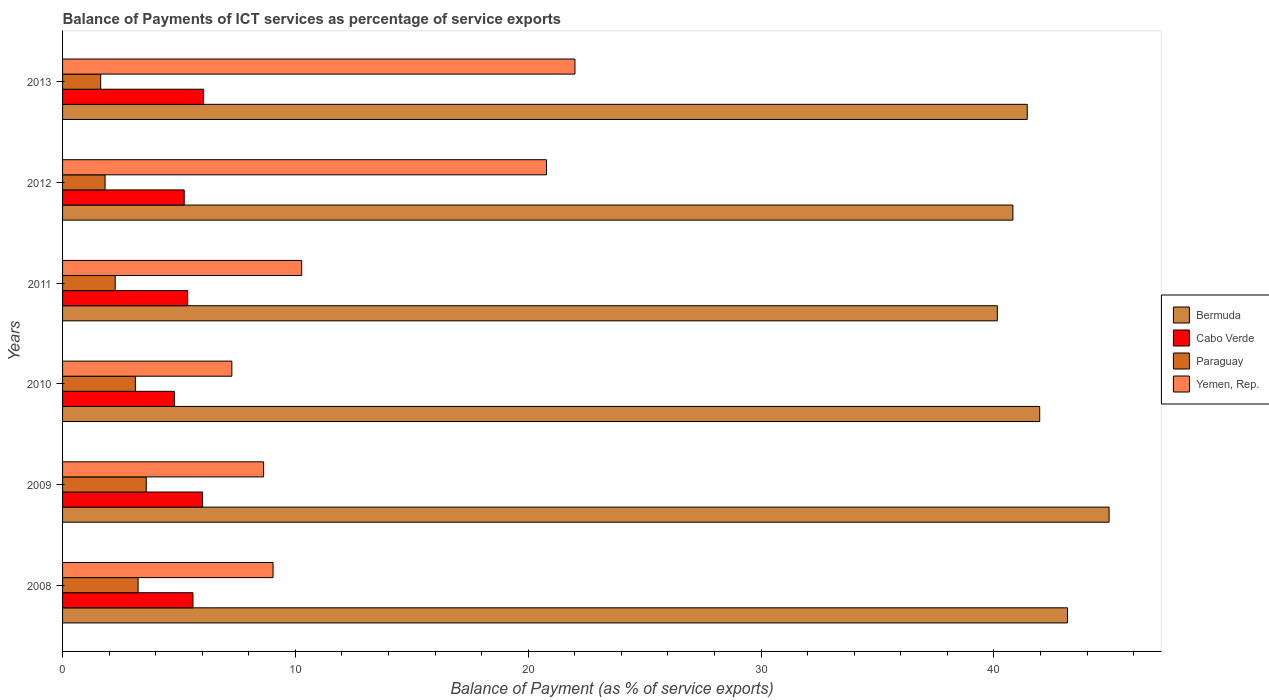How many different coloured bars are there?
Your answer should be compact. 4. Are the number of bars per tick equal to the number of legend labels?
Offer a very short reply. Yes. Are the number of bars on each tick of the Y-axis equal?
Give a very brief answer. Yes. How many bars are there on the 4th tick from the bottom?
Your answer should be compact. 4. What is the balance of payments of ICT services in Cabo Verde in 2010?
Keep it short and to the point. 4.8. Across all years, what is the maximum balance of payments of ICT services in Paraguay?
Offer a very short reply. 3.59. Across all years, what is the minimum balance of payments of ICT services in Cabo Verde?
Offer a terse response. 4.8. In which year was the balance of payments of ICT services in Cabo Verde maximum?
Provide a succinct answer. 2013. What is the total balance of payments of ICT services in Cabo Verde in the graph?
Your answer should be very brief. 33.07. What is the difference between the balance of payments of ICT services in Paraguay in 2011 and that in 2013?
Offer a very short reply. 0.62. What is the difference between the balance of payments of ICT services in Paraguay in 2008 and the balance of payments of ICT services in Cabo Verde in 2013?
Your response must be concise. -2.81. What is the average balance of payments of ICT services in Bermuda per year?
Offer a very short reply. 42.07. In the year 2013, what is the difference between the balance of payments of ICT services in Bermuda and balance of payments of ICT services in Paraguay?
Offer a very short reply. 39.79. In how many years, is the balance of payments of ICT services in Yemen, Rep. greater than 24 %?
Your answer should be compact. 0. What is the ratio of the balance of payments of ICT services in Bermuda in 2009 to that in 2011?
Offer a terse response. 1.12. Is the balance of payments of ICT services in Cabo Verde in 2010 less than that in 2011?
Your answer should be very brief. Yes. Is the difference between the balance of payments of ICT services in Bermuda in 2008 and 2010 greater than the difference between the balance of payments of ICT services in Paraguay in 2008 and 2010?
Make the answer very short. Yes. What is the difference between the highest and the second highest balance of payments of ICT services in Paraguay?
Provide a succinct answer. 0.35. What is the difference between the highest and the lowest balance of payments of ICT services in Paraguay?
Keep it short and to the point. 1.96. Is the sum of the balance of payments of ICT services in Bermuda in 2008 and 2011 greater than the maximum balance of payments of ICT services in Yemen, Rep. across all years?
Keep it short and to the point. Yes. What does the 4th bar from the top in 2008 represents?
Offer a very short reply. Bermuda. What does the 4th bar from the bottom in 2008 represents?
Offer a very short reply. Yemen, Rep. Is it the case that in every year, the sum of the balance of payments of ICT services in Cabo Verde and balance of payments of ICT services in Bermuda is greater than the balance of payments of ICT services in Yemen, Rep.?
Give a very brief answer. Yes. Are all the bars in the graph horizontal?
Your answer should be compact. Yes. How many years are there in the graph?
Ensure brevity in your answer.  6. What is the difference between two consecutive major ticks on the X-axis?
Your response must be concise. 10. Does the graph contain any zero values?
Keep it short and to the point. No. Where does the legend appear in the graph?
Offer a very short reply. Center right. How are the legend labels stacked?
Offer a very short reply. Vertical. What is the title of the graph?
Provide a succinct answer. Balance of Payments of ICT services as percentage of service exports. Does "Lao PDR" appear as one of the legend labels in the graph?
Provide a succinct answer. No. What is the label or title of the X-axis?
Offer a terse response. Balance of Payment (as % of service exports). What is the label or title of the Y-axis?
Make the answer very short. Years. What is the Balance of Payment (as % of service exports) in Bermuda in 2008?
Give a very brief answer. 43.16. What is the Balance of Payment (as % of service exports) in Cabo Verde in 2008?
Your response must be concise. 5.6. What is the Balance of Payment (as % of service exports) in Paraguay in 2008?
Your answer should be very brief. 3.24. What is the Balance of Payment (as % of service exports) of Yemen, Rep. in 2008?
Provide a short and direct response. 9.04. What is the Balance of Payment (as % of service exports) in Bermuda in 2009?
Your answer should be very brief. 44.94. What is the Balance of Payment (as % of service exports) of Cabo Verde in 2009?
Give a very brief answer. 6.01. What is the Balance of Payment (as % of service exports) in Paraguay in 2009?
Your answer should be compact. 3.59. What is the Balance of Payment (as % of service exports) in Yemen, Rep. in 2009?
Your response must be concise. 8.63. What is the Balance of Payment (as % of service exports) of Bermuda in 2010?
Ensure brevity in your answer.  41.96. What is the Balance of Payment (as % of service exports) in Cabo Verde in 2010?
Your response must be concise. 4.8. What is the Balance of Payment (as % of service exports) of Paraguay in 2010?
Offer a terse response. 3.13. What is the Balance of Payment (as % of service exports) in Yemen, Rep. in 2010?
Provide a succinct answer. 7.27. What is the Balance of Payment (as % of service exports) of Bermuda in 2011?
Provide a succinct answer. 40.14. What is the Balance of Payment (as % of service exports) in Cabo Verde in 2011?
Make the answer very short. 5.37. What is the Balance of Payment (as % of service exports) in Paraguay in 2011?
Give a very brief answer. 2.26. What is the Balance of Payment (as % of service exports) in Yemen, Rep. in 2011?
Provide a short and direct response. 10.27. What is the Balance of Payment (as % of service exports) in Bermuda in 2012?
Offer a very short reply. 40.81. What is the Balance of Payment (as % of service exports) in Cabo Verde in 2012?
Your response must be concise. 5.22. What is the Balance of Payment (as % of service exports) of Paraguay in 2012?
Ensure brevity in your answer.  1.83. What is the Balance of Payment (as % of service exports) of Yemen, Rep. in 2012?
Keep it short and to the point. 20.78. What is the Balance of Payment (as % of service exports) in Bermuda in 2013?
Offer a terse response. 41.43. What is the Balance of Payment (as % of service exports) in Cabo Verde in 2013?
Offer a very short reply. 6.05. What is the Balance of Payment (as % of service exports) in Paraguay in 2013?
Give a very brief answer. 1.64. What is the Balance of Payment (as % of service exports) of Yemen, Rep. in 2013?
Provide a succinct answer. 22. Across all years, what is the maximum Balance of Payment (as % of service exports) of Bermuda?
Offer a very short reply. 44.94. Across all years, what is the maximum Balance of Payment (as % of service exports) in Cabo Verde?
Give a very brief answer. 6.05. Across all years, what is the maximum Balance of Payment (as % of service exports) of Paraguay?
Your answer should be compact. 3.59. Across all years, what is the maximum Balance of Payment (as % of service exports) of Yemen, Rep.?
Keep it short and to the point. 22. Across all years, what is the minimum Balance of Payment (as % of service exports) in Bermuda?
Your answer should be compact. 40.14. Across all years, what is the minimum Balance of Payment (as % of service exports) of Cabo Verde?
Your answer should be compact. 4.8. Across all years, what is the minimum Balance of Payment (as % of service exports) in Paraguay?
Ensure brevity in your answer.  1.64. Across all years, what is the minimum Balance of Payment (as % of service exports) in Yemen, Rep.?
Keep it short and to the point. 7.27. What is the total Balance of Payment (as % of service exports) of Bermuda in the graph?
Provide a short and direct response. 252.45. What is the total Balance of Payment (as % of service exports) in Cabo Verde in the graph?
Your answer should be very brief. 33.07. What is the total Balance of Payment (as % of service exports) in Paraguay in the graph?
Provide a short and direct response. 15.69. What is the total Balance of Payment (as % of service exports) in Yemen, Rep. in the graph?
Provide a succinct answer. 78. What is the difference between the Balance of Payment (as % of service exports) of Bermuda in 2008 and that in 2009?
Make the answer very short. -1.79. What is the difference between the Balance of Payment (as % of service exports) in Cabo Verde in 2008 and that in 2009?
Keep it short and to the point. -0.41. What is the difference between the Balance of Payment (as % of service exports) in Paraguay in 2008 and that in 2009?
Your response must be concise. -0.35. What is the difference between the Balance of Payment (as % of service exports) of Yemen, Rep. in 2008 and that in 2009?
Give a very brief answer. 0.41. What is the difference between the Balance of Payment (as % of service exports) of Bermuda in 2008 and that in 2010?
Your answer should be compact. 1.19. What is the difference between the Balance of Payment (as % of service exports) in Cabo Verde in 2008 and that in 2010?
Offer a terse response. 0.8. What is the difference between the Balance of Payment (as % of service exports) in Paraguay in 2008 and that in 2010?
Your answer should be compact. 0.12. What is the difference between the Balance of Payment (as % of service exports) of Yemen, Rep. in 2008 and that in 2010?
Offer a terse response. 1.77. What is the difference between the Balance of Payment (as % of service exports) of Bermuda in 2008 and that in 2011?
Your answer should be compact. 3.01. What is the difference between the Balance of Payment (as % of service exports) in Cabo Verde in 2008 and that in 2011?
Make the answer very short. 0.23. What is the difference between the Balance of Payment (as % of service exports) in Paraguay in 2008 and that in 2011?
Keep it short and to the point. 0.98. What is the difference between the Balance of Payment (as % of service exports) of Yemen, Rep. in 2008 and that in 2011?
Make the answer very short. -1.23. What is the difference between the Balance of Payment (as % of service exports) in Bermuda in 2008 and that in 2012?
Give a very brief answer. 2.34. What is the difference between the Balance of Payment (as % of service exports) of Cabo Verde in 2008 and that in 2012?
Provide a succinct answer. 0.38. What is the difference between the Balance of Payment (as % of service exports) of Paraguay in 2008 and that in 2012?
Ensure brevity in your answer.  1.42. What is the difference between the Balance of Payment (as % of service exports) of Yemen, Rep. in 2008 and that in 2012?
Offer a very short reply. -11.74. What is the difference between the Balance of Payment (as % of service exports) in Bermuda in 2008 and that in 2013?
Provide a succinct answer. 1.73. What is the difference between the Balance of Payment (as % of service exports) in Cabo Verde in 2008 and that in 2013?
Your response must be concise. -0.45. What is the difference between the Balance of Payment (as % of service exports) of Paraguay in 2008 and that in 2013?
Your answer should be very brief. 1.61. What is the difference between the Balance of Payment (as % of service exports) in Yemen, Rep. in 2008 and that in 2013?
Make the answer very short. -12.96. What is the difference between the Balance of Payment (as % of service exports) of Bermuda in 2009 and that in 2010?
Offer a terse response. 2.98. What is the difference between the Balance of Payment (as % of service exports) of Cabo Verde in 2009 and that in 2010?
Provide a succinct answer. 1.21. What is the difference between the Balance of Payment (as % of service exports) in Paraguay in 2009 and that in 2010?
Give a very brief answer. 0.47. What is the difference between the Balance of Payment (as % of service exports) in Yemen, Rep. in 2009 and that in 2010?
Offer a terse response. 1.36. What is the difference between the Balance of Payment (as % of service exports) in Bermuda in 2009 and that in 2011?
Provide a succinct answer. 4.8. What is the difference between the Balance of Payment (as % of service exports) in Cabo Verde in 2009 and that in 2011?
Offer a terse response. 0.64. What is the difference between the Balance of Payment (as % of service exports) in Paraguay in 2009 and that in 2011?
Provide a short and direct response. 1.33. What is the difference between the Balance of Payment (as % of service exports) in Yemen, Rep. in 2009 and that in 2011?
Ensure brevity in your answer.  -1.64. What is the difference between the Balance of Payment (as % of service exports) in Bermuda in 2009 and that in 2012?
Provide a succinct answer. 4.13. What is the difference between the Balance of Payment (as % of service exports) of Cabo Verde in 2009 and that in 2012?
Provide a short and direct response. 0.79. What is the difference between the Balance of Payment (as % of service exports) of Paraguay in 2009 and that in 2012?
Ensure brevity in your answer.  1.77. What is the difference between the Balance of Payment (as % of service exports) of Yemen, Rep. in 2009 and that in 2012?
Keep it short and to the point. -12.15. What is the difference between the Balance of Payment (as % of service exports) in Bermuda in 2009 and that in 2013?
Your response must be concise. 3.51. What is the difference between the Balance of Payment (as % of service exports) of Cabo Verde in 2009 and that in 2013?
Offer a terse response. -0.04. What is the difference between the Balance of Payment (as % of service exports) of Paraguay in 2009 and that in 2013?
Offer a very short reply. 1.96. What is the difference between the Balance of Payment (as % of service exports) in Yemen, Rep. in 2009 and that in 2013?
Your answer should be very brief. -13.37. What is the difference between the Balance of Payment (as % of service exports) of Bermuda in 2010 and that in 2011?
Offer a very short reply. 1.82. What is the difference between the Balance of Payment (as % of service exports) in Cabo Verde in 2010 and that in 2011?
Make the answer very short. -0.57. What is the difference between the Balance of Payment (as % of service exports) of Paraguay in 2010 and that in 2011?
Your answer should be very brief. 0.87. What is the difference between the Balance of Payment (as % of service exports) of Yemen, Rep. in 2010 and that in 2011?
Give a very brief answer. -3. What is the difference between the Balance of Payment (as % of service exports) of Bermuda in 2010 and that in 2012?
Provide a succinct answer. 1.15. What is the difference between the Balance of Payment (as % of service exports) of Cabo Verde in 2010 and that in 2012?
Provide a short and direct response. -0.42. What is the difference between the Balance of Payment (as % of service exports) in Paraguay in 2010 and that in 2012?
Your answer should be compact. 1.3. What is the difference between the Balance of Payment (as % of service exports) in Yemen, Rep. in 2010 and that in 2012?
Provide a succinct answer. -13.51. What is the difference between the Balance of Payment (as % of service exports) of Bermuda in 2010 and that in 2013?
Offer a very short reply. 0.53. What is the difference between the Balance of Payment (as % of service exports) of Cabo Verde in 2010 and that in 2013?
Your answer should be very brief. -1.25. What is the difference between the Balance of Payment (as % of service exports) in Paraguay in 2010 and that in 2013?
Offer a very short reply. 1.49. What is the difference between the Balance of Payment (as % of service exports) in Yemen, Rep. in 2010 and that in 2013?
Offer a very short reply. -14.73. What is the difference between the Balance of Payment (as % of service exports) in Bermuda in 2011 and that in 2012?
Your answer should be compact. -0.67. What is the difference between the Balance of Payment (as % of service exports) of Cabo Verde in 2011 and that in 2012?
Ensure brevity in your answer.  0.15. What is the difference between the Balance of Payment (as % of service exports) of Paraguay in 2011 and that in 2012?
Your response must be concise. 0.44. What is the difference between the Balance of Payment (as % of service exports) of Yemen, Rep. in 2011 and that in 2012?
Give a very brief answer. -10.51. What is the difference between the Balance of Payment (as % of service exports) in Bermuda in 2011 and that in 2013?
Offer a terse response. -1.28. What is the difference between the Balance of Payment (as % of service exports) in Cabo Verde in 2011 and that in 2013?
Make the answer very short. -0.68. What is the difference between the Balance of Payment (as % of service exports) of Paraguay in 2011 and that in 2013?
Keep it short and to the point. 0.62. What is the difference between the Balance of Payment (as % of service exports) of Yemen, Rep. in 2011 and that in 2013?
Offer a very short reply. -11.74. What is the difference between the Balance of Payment (as % of service exports) in Bermuda in 2012 and that in 2013?
Give a very brief answer. -0.62. What is the difference between the Balance of Payment (as % of service exports) in Cabo Verde in 2012 and that in 2013?
Ensure brevity in your answer.  -0.83. What is the difference between the Balance of Payment (as % of service exports) of Paraguay in 2012 and that in 2013?
Offer a very short reply. 0.19. What is the difference between the Balance of Payment (as % of service exports) in Yemen, Rep. in 2012 and that in 2013?
Your response must be concise. -1.22. What is the difference between the Balance of Payment (as % of service exports) of Bermuda in 2008 and the Balance of Payment (as % of service exports) of Cabo Verde in 2009?
Provide a succinct answer. 37.14. What is the difference between the Balance of Payment (as % of service exports) of Bermuda in 2008 and the Balance of Payment (as % of service exports) of Paraguay in 2009?
Make the answer very short. 39.56. What is the difference between the Balance of Payment (as % of service exports) in Bermuda in 2008 and the Balance of Payment (as % of service exports) in Yemen, Rep. in 2009?
Offer a terse response. 34.52. What is the difference between the Balance of Payment (as % of service exports) in Cabo Verde in 2008 and the Balance of Payment (as % of service exports) in Paraguay in 2009?
Offer a very short reply. 2.01. What is the difference between the Balance of Payment (as % of service exports) in Cabo Verde in 2008 and the Balance of Payment (as % of service exports) in Yemen, Rep. in 2009?
Offer a very short reply. -3.03. What is the difference between the Balance of Payment (as % of service exports) of Paraguay in 2008 and the Balance of Payment (as % of service exports) of Yemen, Rep. in 2009?
Make the answer very short. -5.39. What is the difference between the Balance of Payment (as % of service exports) of Bermuda in 2008 and the Balance of Payment (as % of service exports) of Cabo Verde in 2010?
Offer a very short reply. 38.35. What is the difference between the Balance of Payment (as % of service exports) in Bermuda in 2008 and the Balance of Payment (as % of service exports) in Paraguay in 2010?
Your answer should be compact. 40.03. What is the difference between the Balance of Payment (as % of service exports) of Bermuda in 2008 and the Balance of Payment (as % of service exports) of Yemen, Rep. in 2010?
Provide a short and direct response. 35.89. What is the difference between the Balance of Payment (as % of service exports) in Cabo Verde in 2008 and the Balance of Payment (as % of service exports) in Paraguay in 2010?
Your answer should be very brief. 2.47. What is the difference between the Balance of Payment (as % of service exports) in Cabo Verde in 2008 and the Balance of Payment (as % of service exports) in Yemen, Rep. in 2010?
Offer a terse response. -1.67. What is the difference between the Balance of Payment (as % of service exports) in Paraguay in 2008 and the Balance of Payment (as % of service exports) in Yemen, Rep. in 2010?
Your response must be concise. -4.03. What is the difference between the Balance of Payment (as % of service exports) in Bermuda in 2008 and the Balance of Payment (as % of service exports) in Cabo Verde in 2011?
Your response must be concise. 37.78. What is the difference between the Balance of Payment (as % of service exports) in Bermuda in 2008 and the Balance of Payment (as % of service exports) in Paraguay in 2011?
Your response must be concise. 40.9. What is the difference between the Balance of Payment (as % of service exports) in Bermuda in 2008 and the Balance of Payment (as % of service exports) in Yemen, Rep. in 2011?
Your answer should be very brief. 32.89. What is the difference between the Balance of Payment (as % of service exports) in Cabo Verde in 2008 and the Balance of Payment (as % of service exports) in Paraguay in 2011?
Your response must be concise. 3.34. What is the difference between the Balance of Payment (as % of service exports) of Cabo Verde in 2008 and the Balance of Payment (as % of service exports) of Yemen, Rep. in 2011?
Your answer should be very brief. -4.67. What is the difference between the Balance of Payment (as % of service exports) in Paraguay in 2008 and the Balance of Payment (as % of service exports) in Yemen, Rep. in 2011?
Your answer should be very brief. -7.02. What is the difference between the Balance of Payment (as % of service exports) of Bermuda in 2008 and the Balance of Payment (as % of service exports) of Cabo Verde in 2012?
Provide a succinct answer. 37.93. What is the difference between the Balance of Payment (as % of service exports) in Bermuda in 2008 and the Balance of Payment (as % of service exports) in Paraguay in 2012?
Your answer should be very brief. 41.33. What is the difference between the Balance of Payment (as % of service exports) in Bermuda in 2008 and the Balance of Payment (as % of service exports) in Yemen, Rep. in 2012?
Ensure brevity in your answer.  22.37. What is the difference between the Balance of Payment (as % of service exports) of Cabo Verde in 2008 and the Balance of Payment (as % of service exports) of Paraguay in 2012?
Provide a succinct answer. 3.77. What is the difference between the Balance of Payment (as % of service exports) in Cabo Verde in 2008 and the Balance of Payment (as % of service exports) in Yemen, Rep. in 2012?
Your answer should be compact. -15.18. What is the difference between the Balance of Payment (as % of service exports) in Paraguay in 2008 and the Balance of Payment (as % of service exports) in Yemen, Rep. in 2012?
Offer a very short reply. -17.54. What is the difference between the Balance of Payment (as % of service exports) in Bermuda in 2008 and the Balance of Payment (as % of service exports) in Cabo Verde in 2013?
Provide a short and direct response. 37.1. What is the difference between the Balance of Payment (as % of service exports) of Bermuda in 2008 and the Balance of Payment (as % of service exports) of Paraguay in 2013?
Make the answer very short. 41.52. What is the difference between the Balance of Payment (as % of service exports) in Bermuda in 2008 and the Balance of Payment (as % of service exports) in Yemen, Rep. in 2013?
Your answer should be compact. 21.15. What is the difference between the Balance of Payment (as % of service exports) of Cabo Verde in 2008 and the Balance of Payment (as % of service exports) of Paraguay in 2013?
Your answer should be compact. 3.96. What is the difference between the Balance of Payment (as % of service exports) in Cabo Verde in 2008 and the Balance of Payment (as % of service exports) in Yemen, Rep. in 2013?
Your response must be concise. -16.4. What is the difference between the Balance of Payment (as % of service exports) of Paraguay in 2008 and the Balance of Payment (as % of service exports) of Yemen, Rep. in 2013?
Ensure brevity in your answer.  -18.76. What is the difference between the Balance of Payment (as % of service exports) in Bermuda in 2009 and the Balance of Payment (as % of service exports) in Cabo Verde in 2010?
Provide a succinct answer. 40.14. What is the difference between the Balance of Payment (as % of service exports) of Bermuda in 2009 and the Balance of Payment (as % of service exports) of Paraguay in 2010?
Offer a terse response. 41.82. What is the difference between the Balance of Payment (as % of service exports) of Bermuda in 2009 and the Balance of Payment (as % of service exports) of Yemen, Rep. in 2010?
Your answer should be compact. 37.67. What is the difference between the Balance of Payment (as % of service exports) of Cabo Verde in 2009 and the Balance of Payment (as % of service exports) of Paraguay in 2010?
Offer a very short reply. 2.88. What is the difference between the Balance of Payment (as % of service exports) in Cabo Verde in 2009 and the Balance of Payment (as % of service exports) in Yemen, Rep. in 2010?
Ensure brevity in your answer.  -1.26. What is the difference between the Balance of Payment (as % of service exports) in Paraguay in 2009 and the Balance of Payment (as % of service exports) in Yemen, Rep. in 2010?
Provide a succinct answer. -3.68. What is the difference between the Balance of Payment (as % of service exports) in Bermuda in 2009 and the Balance of Payment (as % of service exports) in Cabo Verde in 2011?
Give a very brief answer. 39.57. What is the difference between the Balance of Payment (as % of service exports) of Bermuda in 2009 and the Balance of Payment (as % of service exports) of Paraguay in 2011?
Make the answer very short. 42.68. What is the difference between the Balance of Payment (as % of service exports) of Bermuda in 2009 and the Balance of Payment (as % of service exports) of Yemen, Rep. in 2011?
Your response must be concise. 34.67. What is the difference between the Balance of Payment (as % of service exports) in Cabo Verde in 2009 and the Balance of Payment (as % of service exports) in Paraguay in 2011?
Keep it short and to the point. 3.75. What is the difference between the Balance of Payment (as % of service exports) of Cabo Verde in 2009 and the Balance of Payment (as % of service exports) of Yemen, Rep. in 2011?
Your response must be concise. -4.26. What is the difference between the Balance of Payment (as % of service exports) of Paraguay in 2009 and the Balance of Payment (as % of service exports) of Yemen, Rep. in 2011?
Offer a terse response. -6.67. What is the difference between the Balance of Payment (as % of service exports) in Bermuda in 2009 and the Balance of Payment (as % of service exports) in Cabo Verde in 2012?
Provide a succinct answer. 39.72. What is the difference between the Balance of Payment (as % of service exports) in Bermuda in 2009 and the Balance of Payment (as % of service exports) in Paraguay in 2012?
Your response must be concise. 43.12. What is the difference between the Balance of Payment (as % of service exports) in Bermuda in 2009 and the Balance of Payment (as % of service exports) in Yemen, Rep. in 2012?
Keep it short and to the point. 24.16. What is the difference between the Balance of Payment (as % of service exports) in Cabo Verde in 2009 and the Balance of Payment (as % of service exports) in Paraguay in 2012?
Make the answer very short. 4.19. What is the difference between the Balance of Payment (as % of service exports) in Cabo Verde in 2009 and the Balance of Payment (as % of service exports) in Yemen, Rep. in 2012?
Offer a terse response. -14.77. What is the difference between the Balance of Payment (as % of service exports) of Paraguay in 2009 and the Balance of Payment (as % of service exports) of Yemen, Rep. in 2012?
Offer a terse response. -17.19. What is the difference between the Balance of Payment (as % of service exports) in Bermuda in 2009 and the Balance of Payment (as % of service exports) in Cabo Verde in 2013?
Your answer should be compact. 38.89. What is the difference between the Balance of Payment (as % of service exports) of Bermuda in 2009 and the Balance of Payment (as % of service exports) of Paraguay in 2013?
Keep it short and to the point. 43.3. What is the difference between the Balance of Payment (as % of service exports) of Bermuda in 2009 and the Balance of Payment (as % of service exports) of Yemen, Rep. in 2013?
Ensure brevity in your answer.  22.94. What is the difference between the Balance of Payment (as % of service exports) of Cabo Verde in 2009 and the Balance of Payment (as % of service exports) of Paraguay in 2013?
Your response must be concise. 4.37. What is the difference between the Balance of Payment (as % of service exports) of Cabo Verde in 2009 and the Balance of Payment (as % of service exports) of Yemen, Rep. in 2013?
Your response must be concise. -15.99. What is the difference between the Balance of Payment (as % of service exports) of Paraguay in 2009 and the Balance of Payment (as % of service exports) of Yemen, Rep. in 2013?
Give a very brief answer. -18.41. What is the difference between the Balance of Payment (as % of service exports) of Bermuda in 2010 and the Balance of Payment (as % of service exports) of Cabo Verde in 2011?
Your response must be concise. 36.59. What is the difference between the Balance of Payment (as % of service exports) of Bermuda in 2010 and the Balance of Payment (as % of service exports) of Paraguay in 2011?
Give a very brief answer. 39.7. What is the difference between the Balance of Payment (as % of service exports) in Bermuda in 2010 and the Balance of Payment (as % of service exports) in Yemen, Rep. in 2011?
Your answer should be compact. 31.7. What is the difference between the Balance of Payment (as % of service exports) in Cabo Verde in 2010 and the Balance of Payment (as % of service exports) in Paraguay in 2011?
Offer a terse response. 2.54. What is the difference between the Balance of Payment (as % of service exports) of Cabo Verde in 2010 and the Balance of Payment (as % of service exports) of Yemen, Rep. in 2011?
Your response must be concise. -5.46. What is the difference between the Balance of Payment (as % of service exports) in Paraguay in 2010 and the Balance of Payment (as % of service exports) in Yemen, Rep. in 2011?
Your response must be concise. -7.14. What is the difference between the Balance of Payment (as % of service exports) in Bermuda in 2010 and the Balance of Payment (as % of service exports) in Cabo Verde in 2012?
Offer a terse response. 36.74. What is the difference between the Balance of Payment (as % of service exports) of Bermuda in 2010 and the Balance of Payment (as % of service exports) of Paraguay in 2012?
Give a very brief answer. 40.14. What is the difference between the Balance of Payment (as % of service exports) in Bermuda in 2010 and the Balance of Payment (as % of service exports) in Yemen, Rep. in 2012?
Provide a succinct answer. 21.18. What is the difference between the Balance of Payment (as % of service exports) in Cabo Verde in 2010 and the Balance of Payment (as % of service exports) in Paraguay in 2012?
Keep it short and to the point. 2.98. What is the difference between the Balance of Payment (as % of service exports) in Cabo Verde in 2010 and the Balance of Payment (as % of service exports) in Yemen, Rep. in 2012?
Offer a terse response. -15.98. What is the difference between the Balance of Payment (as % of service exports) of Paraguay in 2010 and the Balance of Payment (as % of service exports) of Yemen, Rep. in 2012?
Your answer should be very brief. -17.65. What is the difference between the Balance of Payment (as % of service exports) in Bermuda in 2010 and the Balance of Payment (as % of service exports) in Cabo Verde in 2013?
Offer a terse response. 35.91. What is the difference between the Balance of Payment (as % of service exports) of Bermuda in 2010 and the Balance of Payment (as % of service exports) of Paraguay in 2013?
Keep it short and to the point. 40.33. What is the difference between the Balance of Payment (as % of service exports) of Bermuda in 2010 and the Balance of Payment (as % of service exports) of Yemen, Rep. in 2013?
Keep it short and to the point. 19.96. What is the difference between the Balance of Payment (as % of service exports) of Cabo Verde in 2010 and the Balance of Payment (as % of service exports) of Paraguay in 2013?
Your answer should be compact. 3.17. What is the difference between the Balance of Payment (as % of service exports) of Cabo Verde in 2010 and the Balance of Payment (as % of service exports) of Yemen, Rep. in 2013?
Provide a succinct answer. -17.2. What is the difference between the Balance of Payment (as % of service exports) of Paraguay in 2010 and the Balance of Payment (as % of service exports) of Yemen, Rep. in 2013?
Offer a very short reply. -18.88. What is the difference between the Balance of Payment (as % of service exports) in Bermuda in 2011 and the Balance of Payment (as % of service exports) in Cabo Verde in 2012?
Make the answer very short. 34.92. What is the difference between the Balance of Payment (as % of service exports) of Bermuda in 2011 and the Balance of Payment (as % of service exports) of Paraguay in 2012?
Offer a terse response. 38.32. What is the difference between the Balance of Payment (as % of service exports) in Bermuda in 2011 and the Balance of Payment (as % of service exports) in Yemen, Rep. in 2012?
Make the answer very short. 19.36. What is the difference between the Balance of Payment (as % of service exports) in Cabo Verde in 2011 and the Balance of Payment (as % of service exports) in Paraguay in 2012?
Offer a very short reply. 3.55. What is the difference between the Balance of Payment (as % of service exports) in Cabo Verde in 2011 and the Balance of Payment (as % of service exports) in Yemen, Rep. in 2012?
Give a very brief answer. -15.41. What is the difference between the Balance of Payment (as % of service exports) in Paraguay in 2011 and the Balance of Payment (as % of service exports) in Yemen, Rep. in 2012?
Offer a very short reply. -18.52. What is the difference between the Balance of Payment (as % of service exports) in Bermuda in 2011 and the Balance of Payment (as % of service exports) in Cabo Verde in 2013?
Provide a short and direct response. 34.09. What is the difference between the Balance of Payment (as % of service exports) of Bermuda in 2011 and the Balance of Payment (as % of service exports) of Paraguay in 2013?
Your answer should be very brief. 38.51. What is the difference between the Balance of Payment (as % of service exports) in Bermuda in 2011 and the Balance of Payment (as % of service exports) in Yemen, Rep. in 2013?
Your response must be concise. 18.14. What is the difference between the Balance of Payment (as % of service exports) in Cabo Verde in 2011 and the Balance of Payment (as % of service exports) in Paraguay in 2013?
Make the answer very short. 3.73. What is the difference between the Balance of Payment (as % of service exports) of Cabo Verde in 2011 and the Balance of Payment (as % of service exports) of Yemen, Rep. in 2013?
Give a very brief answer. -16.63. What is the difference between the Balance of Payment (as % of service exports) in Paraguay in 2011 and the Balance of Payment (as % of service exports) in Yemen, Rep. in 2013?
Your response must be concise. -19.74. What is the difference between the Balance of Payment (as % of service exports) of Bermuda in 2012 and the Balance of Payment (as % of service exports) of Cabo Verde in 2013?
Offer a terse response. 34.76. What is the difference between the Balance of Payment (as % of service exports) in Bermuda in 2012 and the Balance of Payment (as % of service exports) in Paraguay in 2013?
Make the answer very short. 39.17. What is the difference between the Balance of Payment (as % of service exports) of Bermuda in 2012 and the Balance of Payment (as % of service exports) of Yemen, Rep. in 2013?
Provide a short and direct response. 18.81. What is the difference between the Balance of Payment (as % of service exports) in Cabo Verde in 2012 and the Balance of Payment (as % of service exports) in Paraguay in 2013?
Offer a very short reply. 3.59. What is the difference between the Balance of Payment (as % of service exports) in Cabo Verde in 2012 and the Balance of Payment (as % of service exports) in Yemen, Rep. in 2013?
Offer a very short reply. -16.78. What is the difference between the Balance of Payment (as % of service exports) of Paraguay in 2012 and the Balance of Payment (as % of service exports) of Yemen, Rep. in 2013?
Provide a succinct answer. -20.18. What is the average Balance of Payment (as % of service exports) in Bermuda per year?
Offer a terse response. 42.07. What is the average Balance of Payment (as % of service exports) in Cabo Verde per year?
Provide a short and direct response. 5.51. What is the average Balance of Payment (as % of service exports) of Paraguay per year?
Your answer should be compact. 2.62. What is the average Balance of Payment (as % of service exports) of Yemen, Rep. per year?
Give a very brief answer. 13. In the year 2008, what is the difference between the Balance of Payment (as % of service exports) of Bermuda and Balance of Payment (as % of service exports) of Cabo Verde?
Offer a very short reply. 37.56. In the year 2008, what is the difference between the Balance of Payment (as % of service exports) in Bermuda and Balance of Payment (as % of service exports) in Paraguay?
Ensure brevity in your answer.  39.91. In the year 2008, what is the difference between the Balance of Payment (as % of service exports) of Bermuda and Balance of Payment (as % of service exports) of Yemen, Rep.?
Make the answer very short. 34.12. In the year 2008, what is the difference between the Balance of Payment (as % of service exports) in Cabo Verde and Balance of Payment (as % of service exports) in Paraguay?
Provide a short and direct response. 2.36. In the year 2008, what is the difference between the Balance of Payment (as % of service exports) of Cabo Verde and Balance of Payment (as % of service exports) of Yemen, Rep.?
Provide a succinct answer. -3.44. In the year 2008, what is the difference between the Balance of Payment (as % of service exports) of Paraguay and Balance of Payment (as % of service exports) of Yemen, Rep.?
Ensure brevity in your answer.  -5.8. In the year 2009, what is the difference between the Balance of Payment (as % of service exports) in Bermuda and Balance of Payment (as % of service exports) in Cabo Verde?
Make the answer very short. 38.93. In the year 2009, what is the difference between the Balance of Payment (as % of service exports) in Bermuda and Balance of Payment (as % of service exports) in Paraguay?
Offer a very short reply. 41.35. In the year 2009, what is the difference between the Balance of Payment (as % of service exports) of Bermuda and Balance of Payment (as % of service exports) of Yemen, Rep.?
Offer a very short reply. 36.31. In the year 2009, what is the difference between the Balance of Payment (as % of service exports) of Cabo Verde and Balance of Payment (as % of service exports) of Paraguay?
Provide a succinct answer. 2.42. In the year 2009, what is the difference between the Balance of Payment (as % of service exports) in Cabo Verde and Balance of Payment (as % of service exports) in Yemen, Rep.?
Your response must be concise. -2.62. In the year 2009, what is the difference between the Balance of Payment (as % of service exports) of Paraguay and Balance of Payment (as % of service exports) of Yemen, Rep.?
Make the answer very short. -5.04. In the year 2010, what is the difference between the Balance of Payment (as % of service exports) of Bermuda and Balance of Payment (as % of service exports) of Cabo Verde?
Give a very brief answer. 37.16. In the year 2010, what is the difference between the Balance of Payment (as % of service exports) in Bermuda and Balance of Payment (as % of service exports) in Paraguay?
Keep it short and to the point. 38.84. In the year 2010, what is the difference between the Balance of Payment (as % of service exports) in Bermuda and Balance of Payment (as % of service exports) in Yemen, Rep.?
Your response must be concise. 34.69. In the year 2010, what is the difference between the Balance of Payment (as % of service exports) in Cabo Verde and Balance of Payment (as % of service exports) in Paraguay?
Make the answer very short. 1.68. In the year 2010, what is the difference between the Balance of Payment (as % of service exports) in Cabo Verde and Balance of Payment (as % of service exports) in Yemen, Rep.?
Ensure brevity in your answer.  -2.47. In the year 2010, what is the difference between the Balance of Payment (as % of service exports) of Paraguay and Balance of Payment (as % of service exports) of Yemen, Rep.?
Provide a succinct answer. -4.14. In the year 2011, what is the difference between the Balance of Payment (as % of service exports) in Bermuda and Balance of Payment (as % of service exports) in Cabo Verde?
Your answer should be very brief. 34.77. In the year 2011, what is the difference between the Balance of Payment (as % of service exports) of Bermuda and Balance of Payment (as % of service exports) of Paraguay?
Keep it short and to the point. 37.88. In the year 2011, what is the difference between the Balance of Payment (as % of service exports) in Bermuda and Balance of Payment (as % of service exports) in Yemen, Rep.?
Your answer should be very brief. 29.88. In the year 2011, what is the difference between the Balance of Payment (as % of service exports) of Cabo Verde and Balance of Payment (as % of service exports) of Paraguay?
Give a very brief answer. 3.11. In the year 2011, what is the difference between the Balance of Payment (as % of service exports) in Cabo Verde and Balance of Payment (as % of service exports) in Yemen, Rep.?
Your response must be concise. -4.9. In the year 2011, what is the difference between the Balance of Payment (as % of service exports) of Paraguay and Balance of Payment (as % of service exports) of Yemen, Rep.?
Ensure brevity in your answer.  -8.01. In the year 2012, what is the difference between the Balance of Payment (as % of service exports) in Bermuda and Balance of Payment (as % of service exports) in Cabo Verde?
Your answer should be compact. 35.59. In the year 2012, what is the difference between the Balance of Payment (as % of service exports) of Bermuda and Balance of Payment (as % of service exports) of Paraguay?
Give a very brief answer. 38.99. In the year 2012, what is the difference between the Balance of Payment (as % of service exports) in Bermuda and Balance of Payment (as % of service exports) in Yemen, Rep.?
Your answer should be very brief. 20.03. In the year 2012, what is the difference between the Balance of Payment (as % of service exports) in Cabo Verde and Balance of Payment (as % of service exports) in Paraguay?
Your answer should be compact. 3.4. In the year 2012, what is the difference between the Balance of Payment (as % of service exports) of Cabo Verde and Balance of Payment (as % of service exports) of Yemen, Rep.?
Make the answer very short. -15.56. In the year 2012, what is the difference between the Balance of Payment (as % of service exports) of Paraguay and Balance of Payment (as % of service exports) of Yemen, Rep.?
Keep it short and to the point. -18.96. In the year 2013, what is the difference between the Balance of Payment (as % of service exports) of Bermuda and Balance of Payment (as % of service exports) of Cabo Verde?
Offer a terse response. 35.38. In the year 2013, what is the difference between the Balance of Payment (as % of service exports) of Bermuda and Balance of Payment (as % of service exports) of Paraguay?
Ensure brevity in your answer.  39.79. In the year 2013, what is the difference between the Balance of Payment (as % of service exports) of Bermuda and Balance of Payment (as % of service exports) of Yemen, Rep.?
Provide a succinct answer. 19.42. In the year 2013, what is the difference between the Balance of Payment (as % of service exports) of Cabo Verde and Balance of Payment (as % of service exports) of Paraguay?
Your answer should be very brief. 4.42. In the year 2013, what is the difference between the Balance of Payment (as % of service exports) of Cabo Verde and Balance of Payment (as % of service exports) of Yemen, Rep.?
Offer a terse response. -15.95. In the year 2013, what is the difference between the Balance of Payment (as % of service exports) of Paraguay and Balance of Payment (as % of service exports) of Yemen, Rep.?
Make the answer very short. -20.37. What is the ratio of the Balance of Payment (as % of service exports) of Bermuda in 2008 to that in 2009?
Provide a succinct answer. 0.96. What is the ratio of the Balance of Payment (as % of service exports) of Cabo Verde in 2008 to that in 2009?
Give a very brief answer. 0.93. What is the ratio of the Balance of Payment (as % of service exports) in Paraguay in 2008 to that in 2009?
Provide a succinct answer. 0.9. What is the ratio of the Balance of Payment (as % of service exports) in Yemen, Rep. in 2008 to that in 2009?
Ensure brevity in your answer.  1.05. What is the ratio of the Balance of Payment (as % of service exports) in Bermuda in 2008 to that in 2010?
Keep it short and to the point. 1.03. What is the ratio of the Balance of Payment (as % of service exports) of Cabo Verde in 2008 to that in 2010?
Keep it short and to the point. 1.17. What is the ratio of the Balance of Payment (as % of service exports) in Paraguay in 2008 to that in 2010?
Give a very brief answer. 1.04. What is the ratio of the Balance of Payment (as % of service exports) in Yemen, Rep. in 2008 to that in 2010?
Your answer should be very brief. 1.24. What is the ratio of the Balance of Payment (as % of service exports) in Bermuda in 2008 to that in 2011?
Ensure brevity in your answer.  1.07. What is the ratio of the Balance of Payment (as % of service exports) in Cabo Verde in 2008 to that in 2011?
Offer a very short reply. 1.04. What is the ratio of the Balance of Payment (as % of service exports) in Paraguay in 2008 to that in 2011?
Provide a succinct answer. 1.43. What is the ratio of the Balance of Payment (as % of service exports) of Yemen, Rep. in 2008 to that in 2011?
Provide a short and direct response. 0.88. What is the ratio of the Balance of Payment (as % of service exports) of Bermuda in 2008 to that in 2012?
Your answer should be compact. 1.06. What is the ratio of the Balance of Payment (as % of service exports) of Cabo Verde in 2008 to that in 2012?
Keep it short and to the point. 1.07. What is the ratio of the Balance of Payment (as % of service exports) in Paraguay in 2008 to that in 2012?
Offer a very short reply. 1.78. What is the ratio of the Balance of Payment (as % of service exports) in Yemen, Rep. in 2008 to that in 2012?
Offer a terse response. 0.43. What is the ratio of the Balance of Payment (as % of service exports) of Bermuda in 2008 to that in 2013?
Offer a very short reply. 1.04. What is the ratio of the Balance of Payment (as % of service exports) of Cabo Verde in 2008 to that in 2013?
Offer a terse response. 0.93. What is the ratio of the Balance of Payment (as % of service exports) in Paraguay in 2008 to that in 2013?
Provide a short and direct response. 1.98. What is the ratio of the Balance of Payment (as % of service exports) in Yemen, Rep. in 2008 to that in 2013?
Provide a succinct answer. 0.41. What is the ratio of the Balance of Payment (as % of service exports) of Bermuda in 2009 to that in 2010?
Your response must be concise. 1.07. What is the ratio of the Balance of Payment (as % of service exports) in Cabo Verde in 2009 to that in 2010?
Your answer should be compact. 1.25. What is the ratio of the Balance of Payment (as % of service exports) of Paraguay in 2009 to that in 2010?
Provide a short and direct response. 1.15. What is the ratio of the Balance of Payment (as % of service exports) in Yemen, Rep. in 2009 to that in 2010?
Provide a short and direct response. 1.19. What is the ratio of the Balance of Payment (as % of service exports) in Bermuda in 2009 to that in 2011?
Ensure brevity in your answer.  1.12. What is the ratio of the Balance of Payment (as % of service exports) of Cabo Verde in 2009 to that in 2011?
Offer a terse response. 1.12. What is the ratio of the Balance of Payment (as % of service exports) of Paraguay in 2009 to that in 2011?
Make the answer very short. 1.59. What is the ratio of the Balance of Payment (as % of service exports) of Yemen, Rep. in 2009 to that in 2011?
Your answer should be very brief. 0.84. What is the ratio of the Balance of Payment (as % of service exports) in Bermuda in 2009 to that in 2012?
Keep it short and to the point. 1.1. What is the ratio of the Balance of Payment (as % of service exports) in Cabo Verde in 2009 to that in 2012?
Provide a succinct answer. 1.15. What is the ratio of the Balance of Payment (as % of service exports) of Paraguay in 2009 to that in 2012?
Ensure brevity in your answer.  1.97. What is the ratio of the Balance of Payment (as % of service exports) of Yemen, Rep. in 2009 to that in 2012?
Give a very brief answer. 0.42. What is the ratio of the Balance of Payment (as % of service exports) of Bermuda in 2009 to that in 2013?
Make the answer very short. 1.08. What is the ratio of the Balance of Payment (as % of service exports) in Cabo Verde in 2009 to that in 2013?
Ensure brevity in your answer.  0.99. What is the ratio of the Balance of Payment (as % of service exports) in Paraguay in 2009 to that in 2013?
Keep it short and to the point. 2.2. What is the ratio of the Balance of Payment (as % of service exports) of Yemen, Rep. in 2009 to that in 2013?
Offer a terse response. 0.39. What is the ratio of the Balance of Payment (as % of service exports) of Bermuda in 2010 to that in 2011?
Your answer should be compact. 1.05. What is the ratio of the Balance of Payment (as % of service exports) of Cabo Verde in 2010 to that in 2011?
Keep it short and to the point. 0.89. What is the ratio of the Balance of Payment (as % of service exports) of Paraguay in 2010 to that in 2011?
Your response must be concise. 1.38. What is the ratio of the Balance of Payment (as % of service exports) in Yemen, Rep. in 2010 to that in 2011?
Give a very brief answer. 0.71. What is the ratio of the Balance of Payment (as % of service exports) of Bermuda in 2010 to that in 2012?
Ensure brevity in your answer.  1.03. What is the ratio of the Balance of Payment (as % of service exports) of Cabo Verde in 2010 to that in 2012?
Ensure brevity in your answer.  0.92. What is the ratio of the Balance of Payment (as % of service exports) of Paraguay in 2010 to that in 2012?
Offer a terse response. 1.71. What is the ratio of the Balance of Payment (as % of service exports) of Yemen, Rep. in 2010 to that in 2012?
Give a very brief answer. 0.35. What is the ratio of the Balance of Payment (as % of service exports) in Bermuda in 2010 to that in 2013?
Offer a very short reply. 1.01. What is the ratio of the Balance of Payment (as % of service exports) of Cabo Verde in 2010 to that in 2013?
Your answer should be very brief. 0.79. What is the ratio of the Balance of Payment (as % of service exports) in Paraguay in 2010 to that in 2013?
Provide a succinct answer. 1.91. What is the ratio of the Balance of Payment (as % of service exports) in Yemen, Rep. in 2010 to that in 2013?
Your response must be concise. 0.33. What is the ratio of the Balance of Payment (as % of service exports) in Bermuda in 2011 to that in 2012?
Offer a terse response. 0.98. What is the ratio of the Balance of Payment (as % of service exports) in Cabo Verde in 2011 to that in 2012?
Make the answer very short. 1.03. What is the ratio of the Balance of Payment (as % of service exports) in Paraguay in 2011 to that in 2012?
Ensure brevity in your answer.  1.24. What is the ratio of the Balance of Payment (as % of service exports) in Yemen, Rep. in 2011 to that in 2012?
Your response must be concise. 0.49. What is the ratio of the Balance of Payment (as % of service exports) in Cabo Verde in 2011 to that in 2013?
Your answer should be very brief. 0.89. What is the ratio of the Balance of Payment (as % of service exports) of Paraguay in 2011 to that in 2013?
Provide a succinct answer. 1.38. What is the ratio of the Balance of Payment (as % of service exports) in Yemen, Rep. in 2011 to that in 2013?
Make the answer very short. 0.47. What is the ratio of the Balance of Payment (as % of service exports) in Bermuda in 2012 to that in 2013?
Ensure brevity in your answer.  0.99. What is the ratio of the Balance of Payment (as % of service exports) in Cabo Verde in 2012 to that in 2013?
Offer a terse response. 0.86. What is the ratio of the Balance of Payment (as % of service exports) in Paraguay in 2012 to that in 2013?
Provide a succinct answer. 1.11. What is the difference between the highest and the second highest Balance of Payment (as % of service exports) in Bermuda?
Provide a succinct answer. 1.79. What is the difference between the highest and the second highest Balance of Payment (as % of service exports) in Cabo Verde?
Keep it short and to the point. 0.04. What is the difference between the highest and the second highest Balance of Payment (as % of service exports) of Paraguay?
Offer a very short reply. 0.35. What is the difference between the highest and the second highest Balance of Payment (as % of service exports) of Yemen, Rep.?
Your response must be concise. 1.22. What is the difference between the highest and the lowest Balance of Payment (as % of service exports) in Bermuda?
Give a very brief answer. 4.8. What is the difference between the highest and the lowest Balance of Payment (as % of service exports) of Cabo Verde?
Give a very brief answer. 1.25. What is the difference between the highest and the lowest Balance of Payment (as % of service exports) in Paraguay?
Ensure brevity in your answer.  1.96. What is the difference between the highest and the lowest Balance of Payment (as % of service exports) of Yemen, Rep.?
Your response must be concise. 14.73. 